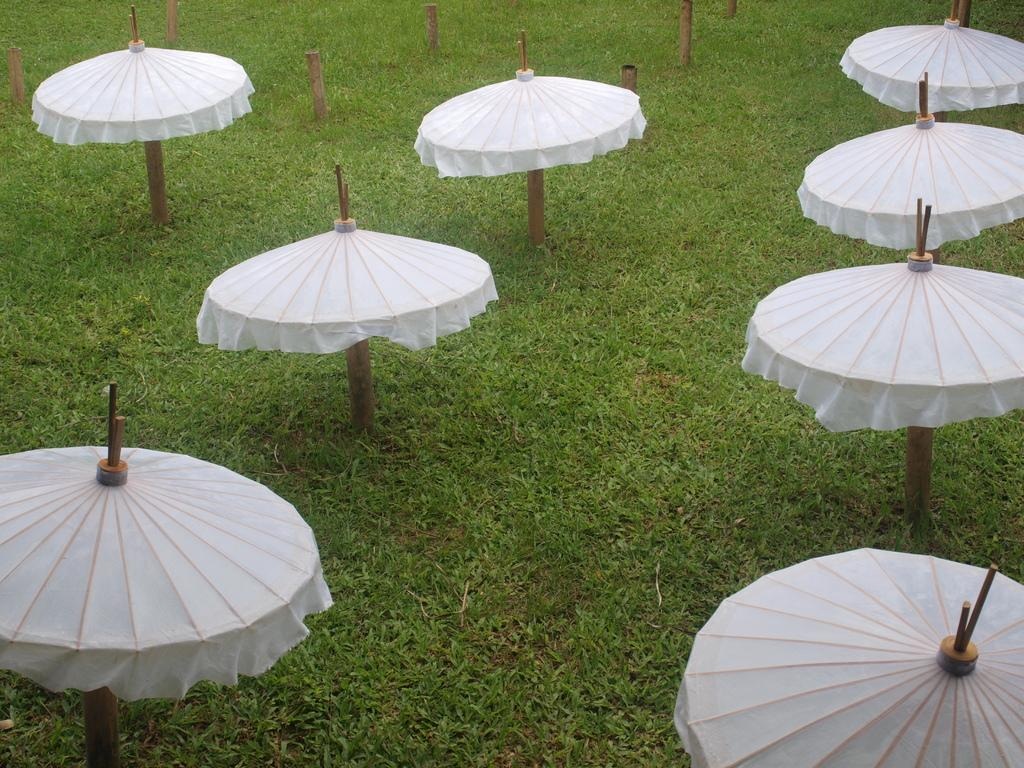What type of surface covers the ground in the image? The ground in the image is covered with grass. What structures can be seen in the image? There are poles visible in the image. Are there any additional features attached to the poles? Some of the poles have umbrellas attached to them. What type of bun is being used to hold the map in the image? There is no bun or map present in the image; it only features poles and umbrellas. 